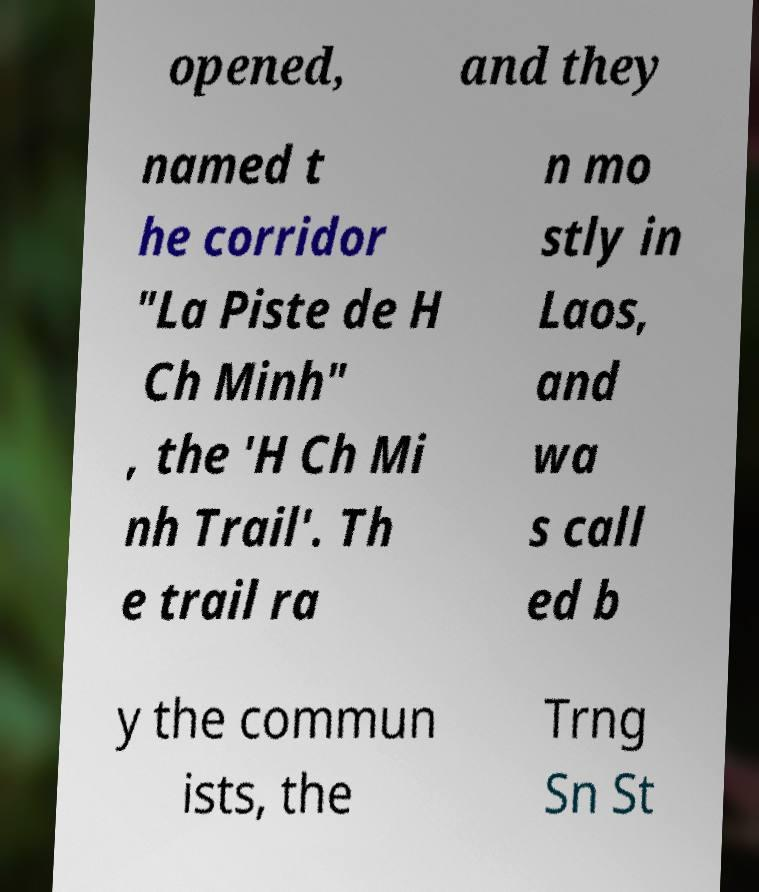For documentation purposes, I need the text within this image transcribed. Could you provide that? opened, and they named t he corridor "La Piste de H Ch Minh" , the 'H Ch Mi nh Trail'. Th e trail ra n mo stly in Laos, and wa s call ed b y the commun ists, the Trng Sn St 